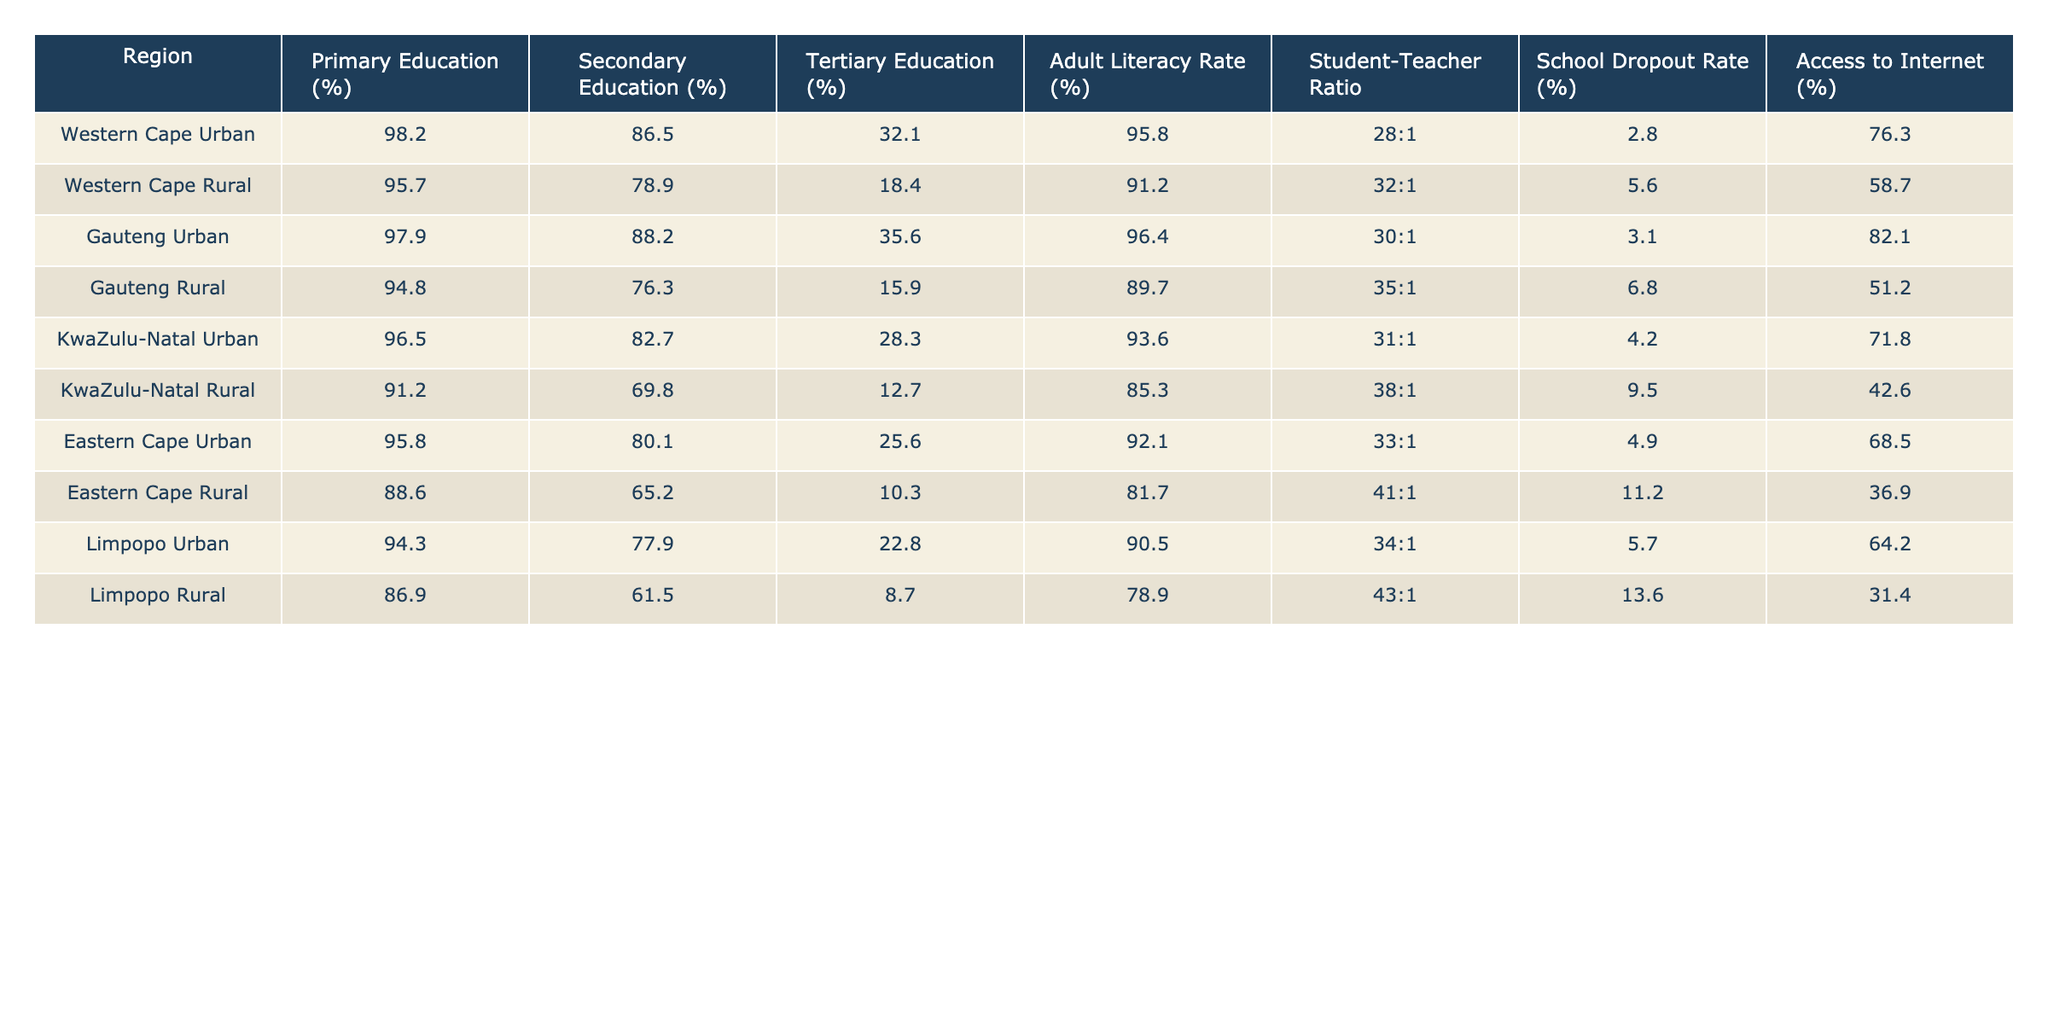What is the primary education percentage in the Gauteng Urban region? Referring to the table, the percentage for primary education in the Gauteng Urban region is listed as 97.9%.
Answer: 97.9% Which region has the highest adult literacy rate? By examining the table, Western Cape Urban shows the highest adult literacy rate at 95.8%.
Answer: 95.8% What is the difference in tertiary education percentages between Western Cape Urban and Western Cape Rural? Tertiary education in Western Cape Urban is 32.1% and in Western Cape Rural it is 18.4%. The difference is calculated as 32.1% - 18.4% = 13.7%.
Answer: 13.7% Is the school dropout rate higher in KwaZulu-Natal Rural compared to Gauteng Urban? The school dropout rate in KwaZulu-Natal Rural is 9.5% while in Gauteng Urban it is 3.1%, thus confirming that KwaZulu-Natal Rural has a higher rate.
Answer: Yes What is the average secondary education percentage for urban regions listed in the table? The percentages for secondary education in urban regions are 86.5% (Western Cape), 88.2% (Gauteng), 82.7% (KwaZulu-Natal), 80.1% (Eastern Cape), and 77.9% (Limpopo). The total is 86.5 + 88.2 + 82.7 + 80.1 + 77.9 = 415.4. The average is 415.4 / 5 = 83.08%.
Answer: 83.08% Which rural region has the lowest access to the internet? Looking at the access to internet percentages, Limpopo Rural has the lowest percentage at 31.4%.
Answer: 31.4% Is it true that all urban regions have a secondary education percentage above 80%? Checking each urban region’s secondary education percentage, all listed are indeed above 80%, confirming the statement as true.
Answer: Yes What is the student-teacher ratio in Eastern Cape Rural, and how does it compare to Western Cape Rural? The student-teacher ratio in Eastern Cape Rural is 41:1 and in Western Cape Rural it is 32:1. This shows that Eastern Cape Rural has a worse ratio.
Answer: 41:1, worse than 32:1 What is the percentage of tertiary education in the Gauteng Rural region compared to the average established for rural regions overall? Gauteng Rural has a tertiary education percentage of 15.9%. The average for all rural regions (Western Cape Rural, Gauteng Rural, KwaZulu-Natal Rural, Eastern Cape Rural, Limpopo Rural) can be calculated: (18.4 + 15.9 + 12.7 + 10.3 + 8.7) / 5 = 13.14%. Since 15.9% is higher than 13.14%, it is above average.
Answer: Above average How much lower is the adult literacy rate in Limpopo Rural compared to Western Cape Urban? Western Cape Urban has an adult literacy rate of 95.8%, while Limpopo Rural has 78.9%. The difference is 95.8% - 78.9% = 16.9%, indicating that Limpopo Rural has a significantly lower rate.
Answer: 16.9% Which region has both the highest primary education and the lowest school dropout rate? The Western Cape Urban region has the highest primary education percentage at 98.2% and the lowest school dropout rate at 2.8%.
Answer: Western Cape Urban 